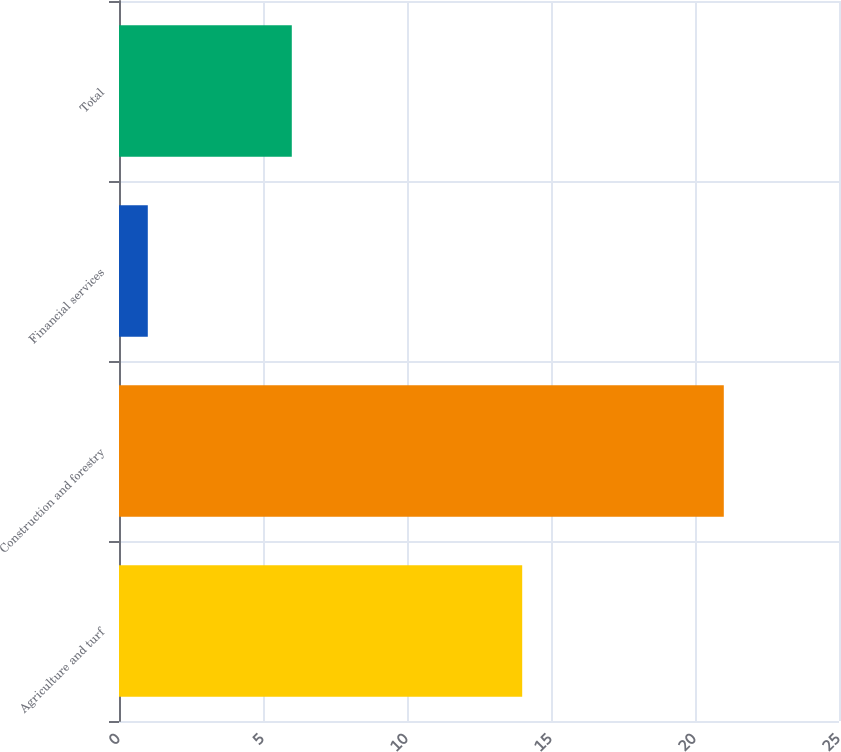Convert chart. <chart><loc_0><loc_0><loc_500><loc_500><bar_chart><fcel>Agriculture and turf<fcel>Construction and forestry<fcel>Financial services<fcel>Total<nl><fcel>14<fcel>21<fcel>1<fcel>6<nl></chart> 